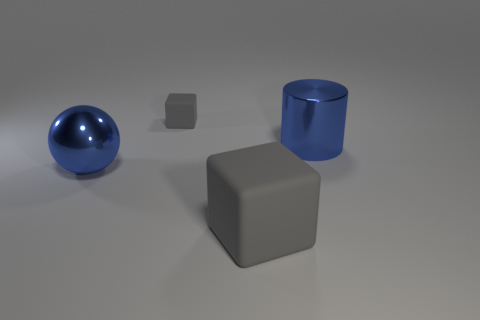How might these objects be used together in a real-world setting? In a real-world setting, these objects could be elements of a decorative ensemble on a desk or shelf. The contrasting shapes and materials could provide visual interest. Alternatively, they might be playthings, like building blocks or toys reflecting different geometrical shapes for educational purposes. 